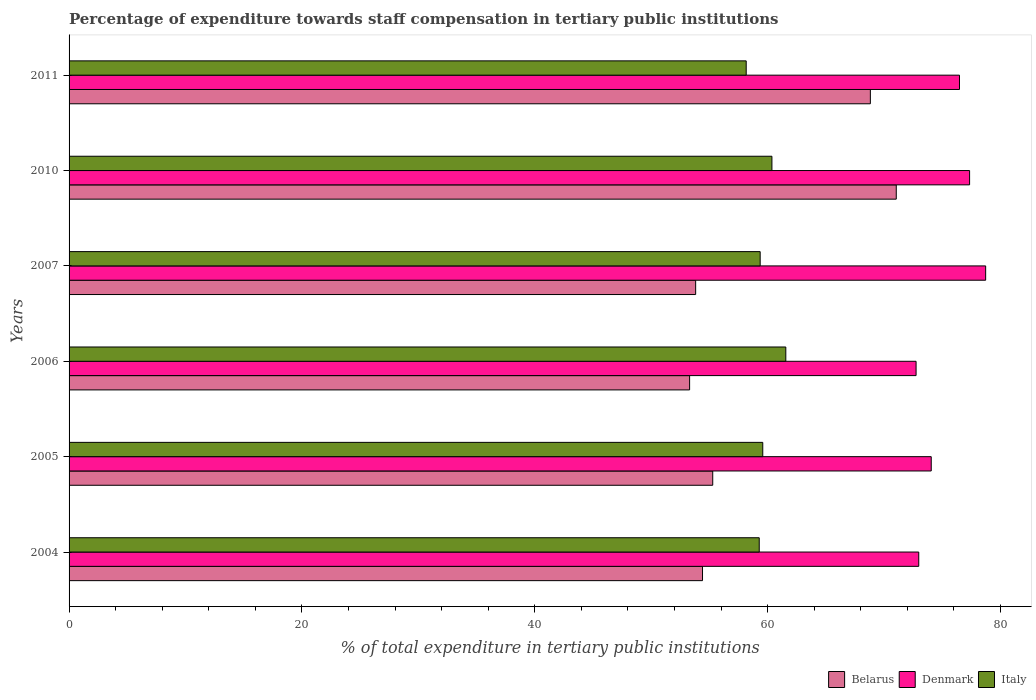How many different coloured bars are there?
Offer a very short reply. 3. What is the label of the 2nd group of bars from the top?
Provide a short and direct response. 2010. In how many cases, is the number of bars for a given year not equal to the number of legend labels?
Ensure brevity in your answer.  0. What is the percentage of expenditure towards staff compensation in Italy in 2010?
Make the answer very short. 60.37. Across all years, what is the maximum percentage of expenditure towards staff compensation in Denmark?
Offer a terse response. 78.73. Across all years, what is the minimum percentage of expenditure towards staff compensation in Italy?
Provide a short and direct response. 58.16. In which year was the percentage of expenditure towards staff compensation in Denmark maximum?
Your answer should be very brief. 2007. In which year was the percentage of expenditure towards staff compensation in Italy minimum?
Give a very brief answer. 2011. What is the total percentage of expenditure towards staff compensation in Italy in the graph?
Your answer should be very brief. 358.33. What is the difference between the percentage of expenditure towards staff compensation in Italy in 2006 and that in 2011?
Keep it short and to the point. 3.4. What is the difference between the percentage of expenditure towards staff compensation in Italy in 2010 and the percentage of expenditure towards staff compensation in Denmark in 2011?
Your answer should be very brief. -16.11. What is the average percentage of expenditure towards staff compensation in Italy per year?
Offer a terse response. 59.72. In the year 2010, what is the difference between the percentage of expenditure towards staff compensation in Denmark and percentage of expenditure towards staff compensation in Italy?
Give a very brief answer. 16.98. In how many years, is the percentage of expenditure towards staff compensation in Italy greater than 32 %?
Give a very brief answer. 6. What is the ratio of the percentage of expenditure towards staff compensation in Belarus in 2007 to that in 2010?
Offer a terse response. 0.76. Is the percentage of expenditure towards staff compensation in Belarus in 2005 less than that in 2006?
Your answer should be compact. No. Is the difference between the percentage of expenditure towards staff compensation in Denmark in 2007 and 2011 greater than the difference between the percentage of expenditure towards staff compensation in Italy in 2007 and 2011?
Keep it short and to the point. Yes. What is the difference between the highest and the second highest percentage of expenditure towards staff compensation in Belarus?
Your response must be concise. 2.23. What is the difference between the highest and the lowest percentage of expenditure towards staff compensation in Denmark?
Make the answer very short. 5.98. In how many years, is the percentage of expenditure towards staff compensation in Denmark greater than the average percentage of expenditure towards staff compensation in Denmark taken over all years?
Keep it short and to the point. 3. Is the sum of the percentage of expenditure towards staff compensation in Italy in 2007 and 2011 greater than the maximum percentage of expenditure towards staff compensation in Denmark across all years?
Your answer should be very brief. Yes. What does the 2nd bar from the top in 2006 represents?
Provide a succinct answer. Denmark. Is it the case that in every year, the sum of the percentage of expenditure towards staff compensation in Italy and percentage of expenditure towards staff compensation in Denmark is greater than the percentage of expenditure towards staff compensation in Belarus?
Offer a very short reply. Yes. How many bars are there?
Offer a terse response. 18. What is the difference between two consecutive major ticks on the X-axis?
Offer a terse response. 20. Where does the legend appear in the graph?
Your answer should be very brief. Bottom right. How many legend labels are there?
Provide a succinct answer. 3. How are the legend labels stacked?
Your response must be concise. Horizontal. What is the title of the graph?
Provide a short and direct response. Percentage of expenditure towards staff compensation in tertiary public institutions. Does "Philippines" appear as one of the legend labels in the graph?
Ensure brevity in your answer.  No. What is the label or title of the X-axis?
Provide a succinct answer. % of total expenditure in tertiary public institutions. What is the % of total expenditure in tertiary public institutions in Belarus in 2004?
Offer a terse response. 54.41. What is the % of total expenditure in tertiary public institutions in Denmark in 2004?
Provide a succinct answer. 72.99. What is the % of total expenditure in tertiary public institutions of Italy in 2004?
Your response must be concise. 59.28. What is the % of total expenditure in tertiary public institutions of Belarus in 2005?
Your answer should be very brief. 55.29. What is the % of total expenditure in tertiary public institutions in Denmark in 2005?
Your answer should be compact. 74.06. What is the % of total expenditure in tertiary public institutions in Italy in 2005?
Give a very brief answer. 59.59. What is the % of total expenditure in tertiary public institutions in Belarus in 2006?
Provide a short and direct response. 53.3. What is the % of total expenditure in tertiary public institutions of Denmark in 2006?
Provide a short and direct response. 72.76. What is the % of total expenditure in tertiary public institutions in Italy in 2006?
Your answer should be compact. 61.57. What is the % of total expenditure in tertiary public institutions of Belarus in 2007?
Your answer should be very brief. 53.82. What is the % of total expenditure in tertiary public institutions in Denmark in 2007?
Your answer should be compact. 78.73. What is the % of total expenditure in tertiary public institutions of Italy in 2007?
Your answer should be compact. 59.36. What is the % of total expenditure in tertiary public institutions in Belarus in 2010?
Your answer should be compact. 71.05. What is the % of total expenditure in tertiary public institutions in Denmark in 2010?
Keep it short and to the point. 77.35. What is the % of total expenditure in tertiary public institutions in Italy in 2010?
Offer a terse response. 60.37. What is the % of total expenditure in tertiary public institutions of Belarus in 2011?
Make the answer very short. 68.83. What is the % of total expenditure in tertiary public institutions of Denmark in 2011?
Ensure brevity in your answer.  76.48. What is the % of total expenditure in tertiary public institutions of Italy in 2011?
Provide a short and direct response. 58.16. Across all years, what is the maximum % of total expenditure in tertiary public institutions of Belarus?
Provide a short and direct response. 71.05. Across all years, what is the maximum % of total expenditure in tertiary public institutions of Denmark?
Offer a very short reply. 78.73. Across all years, what is the maximum % of total expenditure in tertiary public institutions in Italy?
Offer a terse response. 61.57. Across all years, what is the minimum % of total expenditure in tertiary public institutions in Belarus?
Your answer should be compact. 53.3. Across all years, what is the minimum % of total expenditure in tertiary public institutions of Denmark?
Offer a terse response. 72.76. Across all years, what is the minimum % of total expenditure in tertiary public institutions of Italy?
Your answer should be compact. 58.16. What is the total % of total expenditure in tertiary public institutions of Belarus in the graph?
Offer a terse response. 356.71. What is the total % of total expenditure in tertiary public institutions in Denmark in the graph?
Provide a succinct answer. 452.37. What is the total % of total expenditure in tertiary public institutions in Italy in the graph?
Your answer should be compact. 358.33. What is the difference between the % of total expenditure in tertiary public institutions in Belarus in 2004 and that in 2005?
Your answer should be compact. -0.88. What is the difference between the % of total expenditure in tertiary public institutions of Denmark in 2004 and that in 2005?
Keep it short and to the point. -1.07. What is the difference between the % of total expenditure in tertiary public institutions in Italy in 2004 and that in 2005?
Provide a succinct answer. -0.3. What is the difference between the % of total expenditure in tertiary public institutions of Belarus in 2004 and that in 2006?
Keep it short and to the point. 1.11. What is the difference between the % of total expenditure in tertiary public institutions of Denmark in 2004 and that in 2006?
Ensure brevity in your answer.  0.23. What is the difference between the % of total expenditure in tertiary public institutions of Italy in 2004 and that in 2006?
Your response must be concise. -2.28. What is the difference between the % of total expenditure in tertiary public institutions in Belarus in 2004 and that in 2007?
Provide a succinct answer. 0.59. What is the difference between the % of total expenditure in tertiary public institutions of Denmark in 2004 and that in 2007?
Provide a succinct answer. -5.75. What is the difference between the % of total expenditure in tertiary public institutions of Italy in 2004 and that in 2007?
Give a very brief answer. -0.08. What is the difference between the % of total expenditure in tertiary public institutions of Belarus in 2004 and that in 2010?
Provide a succinct answer. -16.64. What is the difference between the % of total expenditure in tertiary public institutions of Denmark in 2004 and that in 2010?
Ensure brevity in your answer.  -4.37. What is the difference between the % of total expenditure in tertiary public institutions of Italy in 2004 and that in 2010?
Offer a terse response. -1.09. What is the difference between the % of total expenditure in tertiary public institutions in Belarus in 2004 and that in 2011?
Provide a short and direct response. -14.42. What is the difference between the % of total expenditure in tertiary public institutions of Denmark in 2004 and that in 2011?
Your response must be concise. -3.5. What is the difference between the % of total expenditure in tertiary public institutions of Italy in 2004 and that in 2011?
Offer a very short reply. 1.12. What is the difference between the % of total expenditure in tertiary public institutions of Belarus in 2005 and that in 2006?
Your response must be concise. 1.99. What is the difference between the % of total expenditure in tertiary public institutions in Denmark in 2005 and that in 2006?
Offer a very short reply. 1.3. What is the difference between the % of total expenditure in tertiary public institutions in Italy in 2005 and that in 2006?
Offer a very short reply. -1.98. What is the difference between the % of total expenditure in tertiary public institutions in Belarus in 2005 and that in 2007?
Provide a short and direct response. 1.47. What is the difference between the % of total expenditure in tertiary public institutions in Denmark in 2005 and that in 2007?
Keep it short and to the point. -4.67. What is the difference between the % of total expenditure in tertiary public institutions in Italy in 2005 and that in 2007?
Keep it short and to the point. 0.22. What is the difference between the % of total expenditure in tertiary public institutions in Belarus in 2005 and that in 2010?
Give a very brief answer. -15.77. What is the difference between the % of total expenditure in tertiary public institutions of Denmark in 2005 and that in 2010?
Your response must be concise. -3.3. What is the difference between the % of total expenditure in tertiary public institutions of Italy in 2005 and that in 2010?
Give a very brief answer. -0.79. What is the difference between the % of total expenditure in tertiary public institutions of Belarus in 2005 and that in 2011?
Provide a short and direct response. -13.54. What is the difference between the % of total expenditure in tertiary public institutions in Denmark in 2005 and that in 2011?
Your answer should be very brief. -2.43. What is the difference between the % of total expenditure in tertiary public institutions of Italy in 2005 and that in 2011?
Your response must be concise. 1.42. What is the difference between the % of total expenditure in tertiary public institutions of Belarus in 2006 and that in 2007?
Give a very brief answer. -0.52. What is the difference between the % of total expenditure in tertiary public institutions of Denmark in 2006 and that in 2007?
Offer a very short reply. -5.98. What is the difference between the % of total expenditure in tertiary public institutions of Italy in 2006 and that in 2007?
Make the answer very short. 2.2. What is the difference between the % of total expenditure in tertiary public institutions of Belarus in 2006 and that in 2010?
Ensure brevity in your answer.  -17.75. What is the difference between the % of total expenditure in tertiary public institutions of Denmark in 2006 and that in 2010?
Your answer should be very brief. -4.6. What is the difference between the % of total expenditure in tertiary public institutions of Italy in 2006 and that in 2010?
Your response must be concise. 1.19. What is the difference between the % of total expenditure in tertiary public institutions of Belarus in 2006 and that in 2011?
Keep it short and to the point. -15.53. What is the difference between the % of total expenditure in tertiary public institutions in Denmark in 2006 and that in 2011?
Give a very brief answer. -3.73. What is the difference between the % of total expenditure in tertiary public institutions in Italy in 2006 and that in 2011?
Your answer should be compact. 3.4. What is the difference between the % of total expenditure in tertiary public institutions in Belarus in 2007 and that in 2010?
Provide a short and direct response. -17.23. What is the difference between the % of total expenditure in tertiary public institutions of Denmark in 2007 and that in 2010?
Your answer should be compact. 1.38. What is the difference between the % of total expenditure in tertiary public institutions in Italy in 2007 and that in 2010?
Provide a short and direct response. -1.01. What is the difference between the % of total expenditure in tertiary public institutions of Belarus in 2007 and that in 2011?
Give a very brief answer. -15.01. What is the difference between the % of total expenditure in tertiary public institutions of Denmark in 2007 and that in 2011?
Your answer should be compact. 2.25. What is the difference between the % of total expenditure in tertiary public institutions in Belarus in 2010 and that in 2011?
Give a very brief answer. 2.23. What is the difference between the % of total expenditure in tertiary public institutions in Denmark in 2010 and that in 2011?
Provide a succinct answer. 0.87. What is the difference between the % of total expenditure in tertiary public institutions in Italy in 2010 and that in 2011?
Make the answer very short. 2.21. What is the difference between the % of total expenditure in tertiary public institutions of Belarus in 2004 and the % of total expenditure in tertiary public institutions of Denmark in 2005?
Your answer should be compact. -19.65. What is the difference between the % of total expenditure in tertiary public institutions in Belarus in 2004 and the % of total expenditure in tertiary public institutions in Italy in 2005?
Your response must be concise. -5.17. What is the difference between the % of total expenditure in tertiary public institutions in Denmark in 2004 and the % of total expenditure in tertiary public institutions in Italy in 2005?
Provide a short and direct response. 13.4. What is the difference between the % of total expenditure in tertiary public institutions of Belarus in 2004 and the % of total expenditure in tertiary public institutions of Denmark in 2006?
Make the answer very short. -18.34. What is the difference between the % of total expenditure in tertiary public institutions of Belarus in 2004 and the % of total expenditure in tertiary public institutions of Italy in 2006?
Ensure brevity in your answer.  -7.15. What is the difference between the % of total expenditure in tertiary public institutions in Denmark in 2004 and the % of total expenditure in tertiary public institutions in Italy in 2006?
Provide a succinct answer. 11.42. What is the difference between the % of total expenditure in tertiary public institutions in Belarus in 2004 and the % of total expenditure in tertiary public institutions in Denmark in 2007?
Offer a terse response. -24.32. What is the difference between the % of total expenditure in tertiary public institutions of Belarus in 2004 and the % of total expenditure in tertiary public institutions of Italy in 2007?
Provide a short and direct response. -4.95. What is the difference between the % of total expenditure in tertiary public institutions in Denmark in 2004 and the % of total expenditure in tertiary public institutions in Italy in 2007?
Provide a succinct answer. 13.62. What is the difference between the % of total expenditure in tertiary public institutions in Belarus in 2004 and the % of total expenditure in tertiary public institutions in Denmark in 2010?
Offer a terse response. -22.94. What is the difference between the % of total expenditure in tertiary public institutions of Belarus in 2004 and the % of total expenditure in tertiary public institutions of Italy in 2010?
Offer a terse response. -5.96. What is the difference between the % of total expenditure in tertiary public institutions in Denmark in 2004 and the % of total expenditure in tertiary public institutions in Italy in 2010?
Your answer should be compact. 12.61. What is the difference between the % of total expenditure in tertiary public institutions of Belarus in 2004 and the % of total expenditure in tertiary public institutions of Denmark in 2011?
Your answer should be compact. -22.07. What is the difference between the % of total expenditure in tertiary public institutions in Belarus in 2004 and the % of total expenditure in tertiary public institutions in Italy in 2011?
Give a very brief answer. -3.75. What is the difference between the % of total expenditure in tertiary public institutions in Denmark in 2004 and the % of total expenditure in tertiary public institutions in Italy in 2011?
Provide a short and direct response. 14.82. What is the difference between the % of total expenditure in tertiary public institutions in Belarus in 2005 and the % of total expenditure in tertiary public institutions in Denmark in 2006?
Your answer should be compact. -17.47. What is the difference between the % of total expenditure in tertiary public institutions of Belarus in 2005 and the % of total expenditure in tertiary public institutions of Italy in 2006?
Your answer should be very brief. -6.28. What is the difference between the % of total expenditure in tertiary public institutions of Denmark in 2005 and the % of total expenditure in tertiary public institutions of Italy in 2006?
Your answer should be very brief. 12.49. What is the difference between the % of total expenditure in tertiary public institutions of Belarus in 2005 and the % of total expenditure in tertiary public institutions of Denmark in 2007?
Make the answer very short. -23.44. What is the difference between the % of total expenditure in tertiary public institutions in Belarus in 2005 and the % of total expenditure in tertiary public institutions in Italy in 2007?
Keep it short and to the point. -4.07. What is the difference between the % of total expenditure in tertiary public institutions of Denmark in 2005 and the % of total expenditure in tertiary public institutions of Italy in 2007?
Offer a terse response. 14.69. What is the difference between the % of total expenditure in tertiary public institutions of Belarus in 2005 and the % of total expenditure in tertiary public institutions of Denmark in 2010?
Ensure brevity in your answer.  -22.06. What is the difference between the % of total expenditure in tertiary public institutions of Belarus in 2005 and the % of total expenditure in tertiary public institutions of Italy in 2010?
Keep it short and to the point. -5.08. What is the difference between the % of total expenditure in tertiary public institutions in Denmark in 2005 and the % of total expenditure in tertiary public institutions in Italy in 2010?
Ensure brevity in your answer.  13.69. What is the difference between the % of total expenditure in tertiary public institutions in Belarus in 2005 and the % of total expenditure in tertiary public institutions in Denmark in 2011?
Ensure brevity in your answer.  -21.2. What is the difference between the % of total expenditure in tertiary public institutions in Belarus in 2005 and the % of total expenditure in tertiary public institutions in Italy in 2011?
Ensure brevity in your answer.  -2.87. What is the difference between the % of total expenditure in tertiary public institutions in Denmark in 2005 and the % of total expenditure in tertiary public institutions in Italy in 2011?
Give a very brief answer. 15.89. What is the difference between the % of total expenditure in tertiary public institutions of Belarus in 2006 and the % of total expenditure in tertiary public institutions of Denmark in 2007?
Provide a succinct answer. -25.43. What is the difference between the % of total expenditure in tertiary public institutions of Belarus in 2006 and the % of total expenditure in tertiary public institutions of Italy in 2007?
Offer a terse response. -6.06. What is the difference between the % of total expenditure in tertiary public institutions in Denmark in 2006 and the % of total expenditure in tertiary public institutions in Italy in 2007?
Offer a terse response. 13.39. What is the difference between the % of total expenditure in tertiary public institutions of Belarus in 2006 and the % of total expenditure in tertiary public institutions of Denmark in 2010?
Keep it short and to the point. -24.05. What is the difference between the % of total expenditure in tertiary public institutions in Belarus in 2006 and the % of total expenditure in tertiary public institutions in Italy in 2010?
Make the answer very short. -7.07. What is the difference between the % of total expenditure in tertiary public institutions in Denmark in 2006 and the % of total expenditure in tertiary public institutions in Italy in 2010?
Your response must be concise. 12.38. What is the difference between the % of total expenditure in tertiary public institutions in Belarus in 2006 and the % of total expenditure in tertiary public institutions in Denmark in 2011?
Ensure brevity in your answer.  -23.18. What is the difference between the % of total expenditure in tertiary public institutions in Belarus in 2006 and the % of total expenditure in tertiary public institutions in Italy in 2011?
Ensure brevity in your answer.  -4.86. What is the difference between the % of total expenditure in tertiary public institutions in Denmark in 2006 and the % of total expenditure in tertiary public institutions in Italy in 2011?
Provide a succinct answer. 14.59. What is the difference between the % of total expenditure in tertiary public institutions of Belarus in 2007 and the % of total expenditure in tertiary public institutions of Denmark in 2010?
Your answer should be compact. -23.53. What is the difference between the % of total expenditure in tertiary public institutions of Belarus in 2007 and the % of total expenditure in tertiary public institutions of Italy in 2010?
Your response must be concise. -6.55. What is the difference between the % of total expenditure in tertiary public institutions of Denmark in 2007 and the % of total expenditure in tertiary public institutions of Italy in 2010?
Provide a succinct answer. 18.36. What is the difference between the % of total expenditure in tertiary public institutions in Belarus in 2007 and the % of total expenditure in tertiary public institutions in Denmark in 2011?
Give a very brief answer. -22.66. What is the difference between the % of total expenditure in tertiary public institutions in Belarus in 2007 and the % of total expenditure in tertiary public institutions in Italy in 2011?
Your answer should be very brief. -4.34. What is the difference between the % of total expenditure in tertiary public institutions in Denmark in 2007 and the % of total expenditure in tertiary public institutions in Italy in 2011?
Provide a short and direct response. 20.57. What is the difference between the % of total expenditure in tertiary public institutions of Belarus in 2010 and the % of total expenditure in tertiary public institutions of Denmark in 2011?
Your response must be concise. -5.43. What is the difference between the % of total expenditure in tertiary public institutions of Belarus in 2010 and the % of total expenditure in tertiary public institutions of Italy in 2011?
Provide a short and direct response. 12.89. What is the difference between the % of total expenditure in tertiary public institutions of Denmark in 2010 and the % of total expenditure in tertiary public institutions of Italy in 2011?
Provide a short and direct response. 19.19. What is the average % of total expenditure in tertiary public institutions in Belarus per year?
Provide a short and direct response. 59.45. What is the average % of total expenditure in tertiary public institutions in Denmark per year?
Your answer should be compact. 75.39. What is the average % of total expenditure in tertiary public institutions in Italy per year?
Provide a succinct answer. 59.72. In the year 2004, what is the difference between the % of total expenditure in tertiary public institutions in Belarus and % of total expenditure in tertiary public institutions in Denmark?
Your answer should be very brief. -18.57. In the year 2004, what is the difference between the % of total expenditure in tertiary public institutions in Belarus and % of total expenditure in tertiary public institutions in Italy?
Ensure brevity in your answer.  -4.87. In the year 2004, what is the difference between the % of total expenditure in tertiary public institutions in Denmark and % of total expenditure in tertiary public institutions in Italy?
Offer a very short reply. 13.7. In the year 2005, what is the difference between the % of total expenditure in tertiary public institutions in Belarus and % of total expenditure in tertiary public institutions in Denmark?
Ensure brevity in your answer.  -18.77. In the year 2005, what is the difference between the % of total expenditure in tertiary public institutions of Belarus and % of total expenditure in tertiary public institutions of Italy?
Your answer should be compact. -4.3. In the year 2005, what is the difference between the % of total expenditure in tertiary public institutions of Denmark and % of total expenditure in tertiary public institutions of Italy?
Offer a very short reply. 14.47. In the year 2006, what is the difference between the % of total expenditure in tertiary public institutions of Belarus and % of total expenditure in tertiary public institutions of Denmark?
Offer a very short reply. -19.45. In the year 2006, what is the difference between the % of total expenditure in tertiary public institutions in Belarus and % of total expenditure in tertiary public institutions in Italy?
Keep it short and to the point. -8.26. In the year 2006, what is the difference between the % of total expenditure in tertiary public institutions of Denmark and % of total expenditure in tertiary public institutions of Italy?
Give a very brief answer. 11.19. In the year 2007, what is the difference between the % of total expenditure in tertiary public institutions of Belarus and % of total expenditure in tertiary public institutions of Denmark?
Keep it short and to the point. -24.91. In the year 2007, what is the difference between the % of total expenditure in tertiary public institutions in Belarus and % of total expenditure in tertiary public institutions in Italy?
Your response must be concise. -5.54. In the year 2007, what is the difference between the % of total expenditure in tertiary public institutions in Denmark and % of total expenditure in tertiary public institutions in Italy?
Your answer should be compact. 19.37. In the year 2010, what is the difference between the % of total expenditure in tertiary public institutions of Belarus and % of total expenditure in tertiary public institutions of Denmark?
Provide a succinct answer. -6.3. In the year 2010, what is the difference between the % of total expenditure in tertiary public institutions of Belarus and % of total expenditure in tertiary public institutions of Italy?
Your answer should be compact. 10.68. In the year 2010, what is the difference between the % of total expenditure in tertiary public institutions in Denmark and % of total expenditure in tertiary public institutions in Italy?
Offer a terse response. 16.98. In the year 2011, what is the difference between the % of total expenditure in tertiary public institutions in Belarus and % of total expenditure in tertiary public institutions in Denmark?
Your response must be concise. -7.66. In the year 2011, what is the difference between the % of total expenditure in tertiary public institutions of Belarus and % of total expenditure in tertiary public institutions of Italy?
Offer a terse response. 10.66. In the year 2011, what is the difference between the % of total expenditure in tertiary public institutions of Denmark and % of total expenditure in tertiary public institutions of Italy?
Keep it short and to the point. 18.32. What is the ratio of the % of total expenditure in tertiary public institutions in Belarus in 2004 to that in 2005?
Provide a short and direct response. 0.98. What is the ratio of the % of total expenditure in tertiary public institutions of Denmark in 2004 to that in 2005?
Make the answer very short. 0.99. What is the ratio of the % of total expenditure in tertiary public institutions in Italy in 2004 to that in 2005?
Your response must be concise. 0.99. What is the ratio of the % of total expenditure in tertiary public institutions in Belarus in 2004 to that in 2006?
Offer a terse response. 1.02. What is the ratio of the % of total expenditure in tertiary public institutions of Italy in 2004 to that in 2006?
Make the answer very short. 0.96. What is the ratio of the % of total expenditure in tertiary public institutions of Belarus in 2004 to that in 2007?
Your answer should be very brief. 1.01. What is the ratio of the % of total expenditure in tertiary public institutions of Denmark in 2004 to that in 2007?
Provide a short and direct response. 0.93. What is the ratio of the % of total expenditure in tertiary public institutions in Belarus in 2004 to that in 2010?
Your answer should be very brief. 0.77. What is the ratio of the % of total expenditure in tertiary public institutions of Denmark in 2004 to that in 2010?
Provide a succinct answer. 0.94. What is the ratio of the % of total expenditure in tertiary public institutions in Belarus in 2004 to that in 2011?
Keep it short and to the point. 0.79. What is the ratio of the % of total expenditure in tertiary public institutions in Denmark in 2004 to that in 2011?
Make the answer very short. 0.95. What is the ratio of the % of total expenditure in tertiary public institutions of Italy in 2004 to that in 2011?
Your answer should be very brief. 1.02. What is the ratio of the % of total expenditure in tertiary public institutions in Belarus in 2005 to that in 2006?
Provide a succinct answer. 1.04. What is the ratio of the % of total expenditure in tertiary public institutions in Denmark in 2005 to that in 2006?
Keep it short and to the point. 1.02. What is the ratio of the % of total expenditure in tertiary public institutions of Italy in 2005 to that in 2006?
Ensure brevity in your answer.  0.97. What is the ratio of the % of total expenditure in tertiary public institutions in Belarus in 2005 to that in 2007?
Provide a short and direct response. 1.03. What is the ratio of the % of total expenditure in tertiary public institutions in Denmark in 2005 to that in 2007?
Provide a succinct answer. 0.94. What is the ratio of the % of total expenditure in tertiary public institutions of Italy in 2005 to that in 2007?
Your response must be concise. 1. What is the ratio of the % of total expenditure in tertiary public institutions in Belarus in 2005 to that in 2010?
Provide a short and direct response. 0.78. What is the ratio of the % of total expenditure in tertiary public institutions of Denmark in 2005 to that in 2010?
Give a very brief answer. 0.96. What is the ratio of the % of total expenditure in tertiary public institutions of Belarus in 2005 to that in 2011?
Offer a very short reply. 0.8. What is the ratio of the % of total expenditure in tertiary public institutions in Denmark in 2005 to that in 2011?
Keep it short and to the point. 0.97. What is the ratio of the % of total expenditure in tertiary public institutions of Italy in 2005 to that in 2011?
Give a very brief answer. 1.02. What is the ratio of the % of total expenditure in tertiary public institutions of Belarus in 2006 to that in 2007?
Make the answer very short. 0.99. What is the ratio of the % of total expenditure in tertiary public institutions in Denmark in 2006 to that in 2007?
Give a very brief answer. 0.92. What is the ratio of the % of total expenditure in tertiary public institutions in Italy in 2006 to that in 2007?
Make the answer very short. 1.04. What is the ratio of the % of total expenditure in tertiary public institutions in Belarus in 2006 to that in 2010?
Make the answer very short. 0.75. What is the ratio of the % of total expenditure in tertiary public institutions of Denmark in 2006 to that in 2010?
Make the answer very short. 0.94. What is the ratio of the % of total expenditure in tertiary public institutions in Italy in 2006 to that in 2010?
Keep it short and to the point. 1.02. What is the ratio of the % of total expenditure in tertiary public institutions in Belarus in 2006 to that in 2011?
Provide a short and direct response. 0.77. What is the ratio of the % of total expenditure in tertiary public institutions of Denmark in 2006 to that in 2011?
Offer a terse response. 0.95. What is the ratio of the % of total expenditure in tertiary public institutions in Italy in 2006 to that in 2011?
Make the answer very short. 1.06. What is the ratio of the % of total expenditure in tertiary public institutions of Belarus in 2007 to that in 2010?
Provide a short and direct response. 0.76. What is the ratio of the % of total expenditure in tertiary public institutions in Denmark in 2007 to that in 2010?
Offer a very short reply. 1.02. What is the ratio of the % of total expenditure in tertiary public institutions of Italy in 2007 to that in 2010?
Your answer should be compact. 0.98. What is the ratio of the % of total expenditure in tertiary public institutions of Belarus in 2007 to that in 2011?
Offer a terse response. 0.78. What is the ratio of the % of total expenditure in tertiary public institutions in Denmark in 2007 to that in 2011?
Ensure brevity in your answer.  1.03. What is the ratio of the % of total expenditure in tertiary public institutions in Italy in 2007 to that in 2011?
Your answer should be compact. 1.02. What is the ratio of the % of total expenditure in tertiary public institutions in Belarus in 2010 to that in 2011?
Give a very brief answer. 1.03. What is the ratio of the % of total expenditure in tertiary public institutions in Denmark in 2010 to that in 2011?
Provide a short and direct response. 1.01. What is the ratio of the % of total expenditure in tertiary public institutions in Italy in 2010 to that in 2011?
Your answer should be compact. 1.04. What is the difference between the highest and the second highest % of total expenditure in tertiary public institutions of Belarus?
Give a very brief answer. 2.23. What is the difference between the highest and the second highest % of total expenditure in tertiary public institutions in Denmark?
Give a very brief answer. 1.38. What is the difference between the highest and the second highest % of total expenditure in tertiary public institutions of Italy?
Your answer should be compact. 1.19. What is the difference between the highest and the lowest % of total expenditure in tertiary public institutions of Belarus?
Offer a terse response. 17.75. What is the difference between the highest and the lowest % of total expenditure in tertiary public institutions in Denmark?
Your answer should be compact. 5.98. What is the difference between the highest and the lowest % of total expenditure in tertiary public institutions of Italy?
Provide a short and direct response. 3.4. 